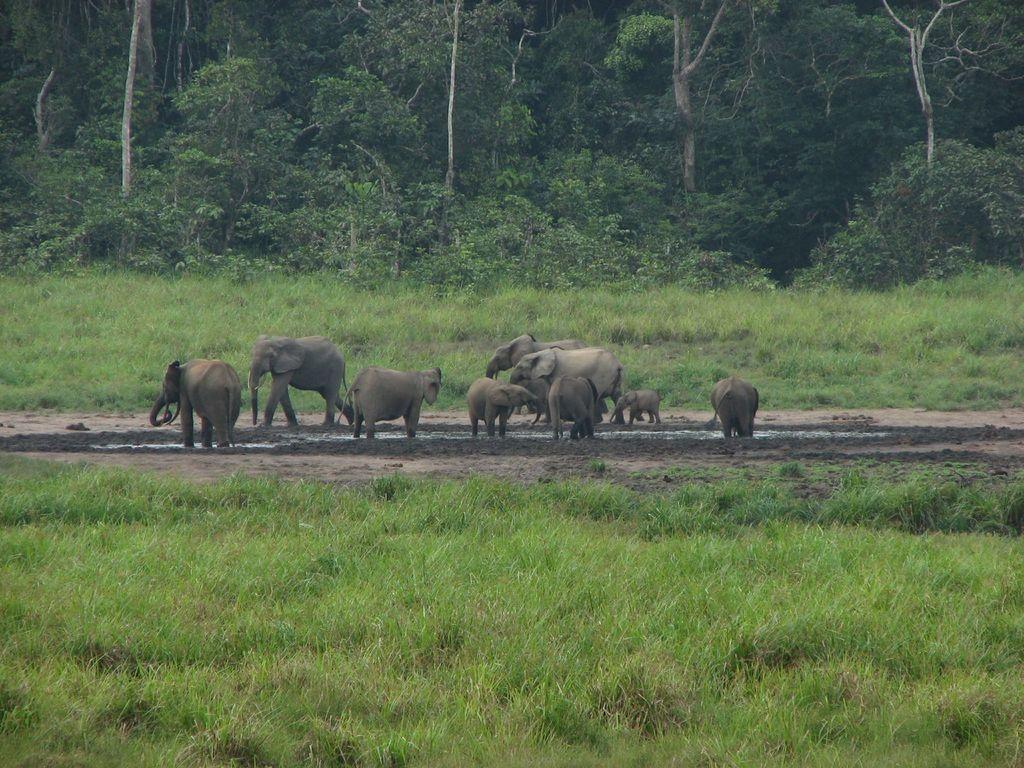How would you summarize this image in a sentence or two? In the image there are few elephants standing and walking on the land with grass on either side of it and in the back there are trees. 